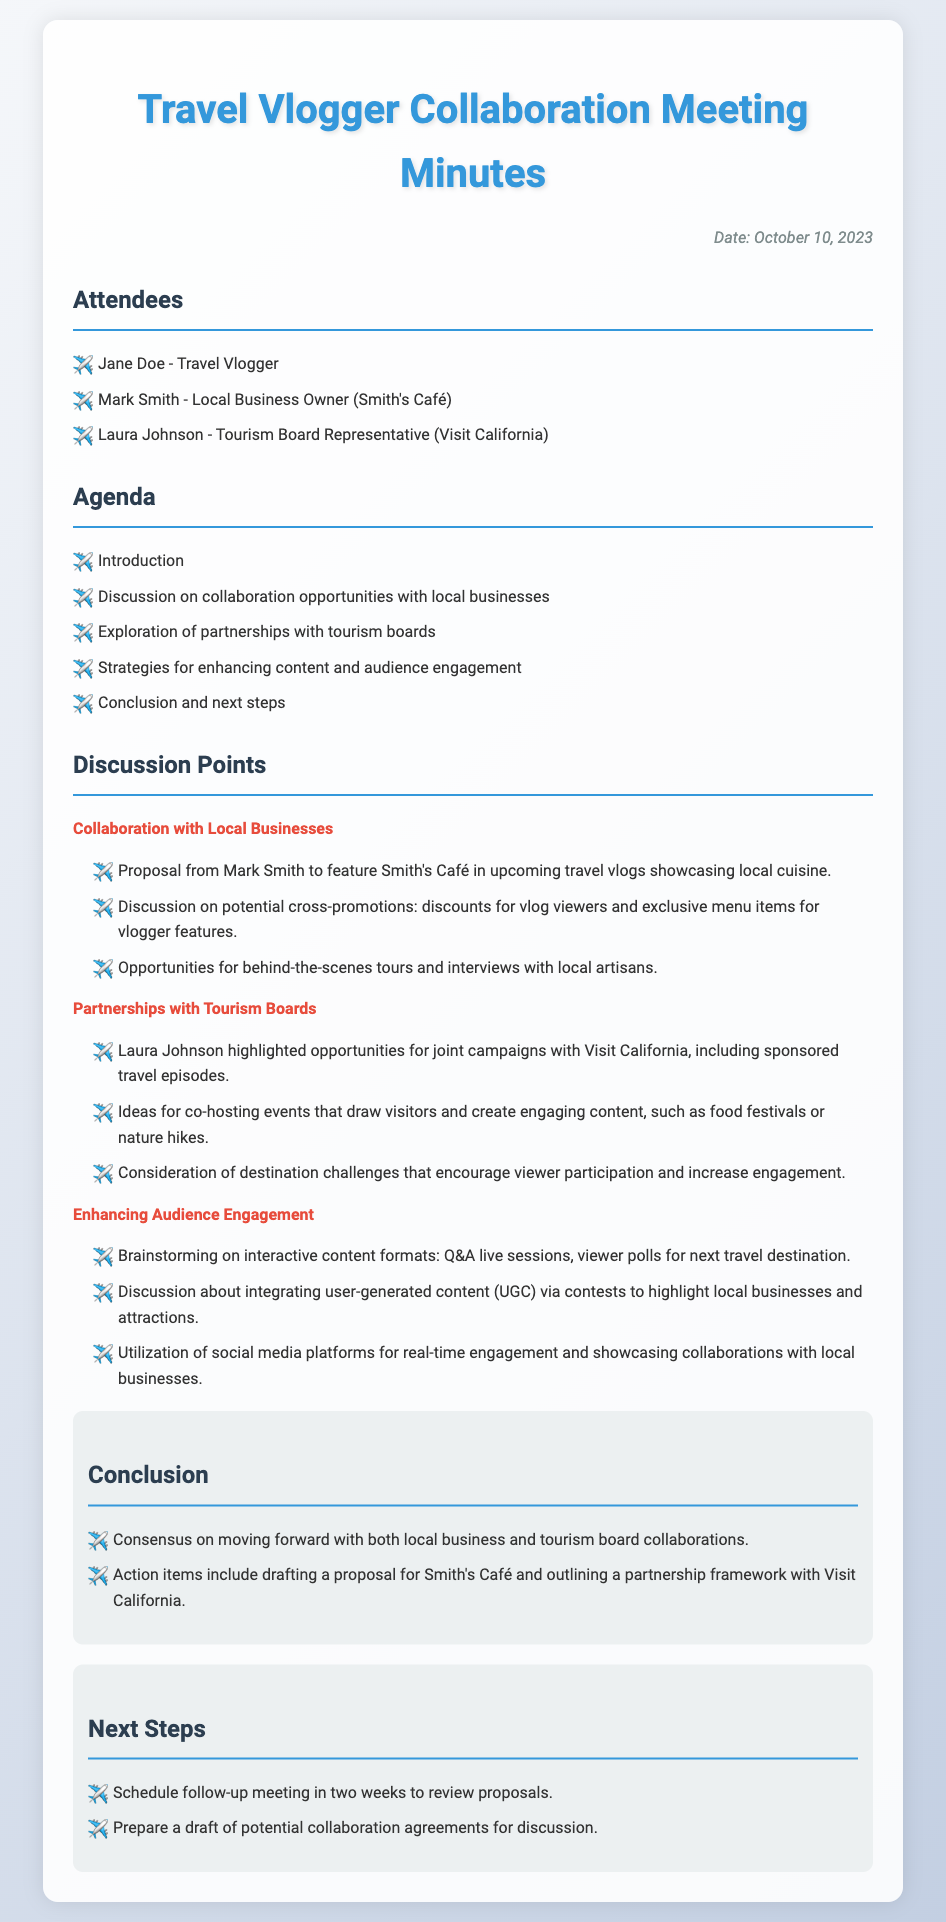What is the date of the meeting? The date of the meeting is mentioned at the top of the document as October 10, 2023.
Answer: October 10, 2023 Who proposed featuring Smith's Café? The proposal to feature Smith's Café in travel vlogs came from Mark Smith, a local business owner.
Answer: Mark Smith What organization does Laura Johnson represent? Laura Johnson is identified as the representative of the tourism board in the document.
Answer: Visit California What type of events were discussed for co-hosting? Co-hosting events such as food festivals or nature hikes were suggested as a way to draw visitors and create engaging content.
Answer: Food festivals or nature hikes What was the consensus at the conclusion of the meeting? The conclusion includes a consensus on moving forward with collaborations with both local businesses and tourism boards.
Answer: Moving forward with collaborations How many weeks until the follow-up meeting is scheduled? The next steps include scheduling a follow-up meeting in two weeks.
Answer: Two weeks What action item involves Smith's Café? An action item regarding Smith's Café includes drafting a proposal for the café for future collaboration.
Answer: Drafting a proposal for Smith's Café What kind of content formats were brainstormed for audience engagement? The discussion included brainstorming interactive content formats such as Q&A live sessions and viewer polls.
Answer: Q&A live sessions, viewer polls 